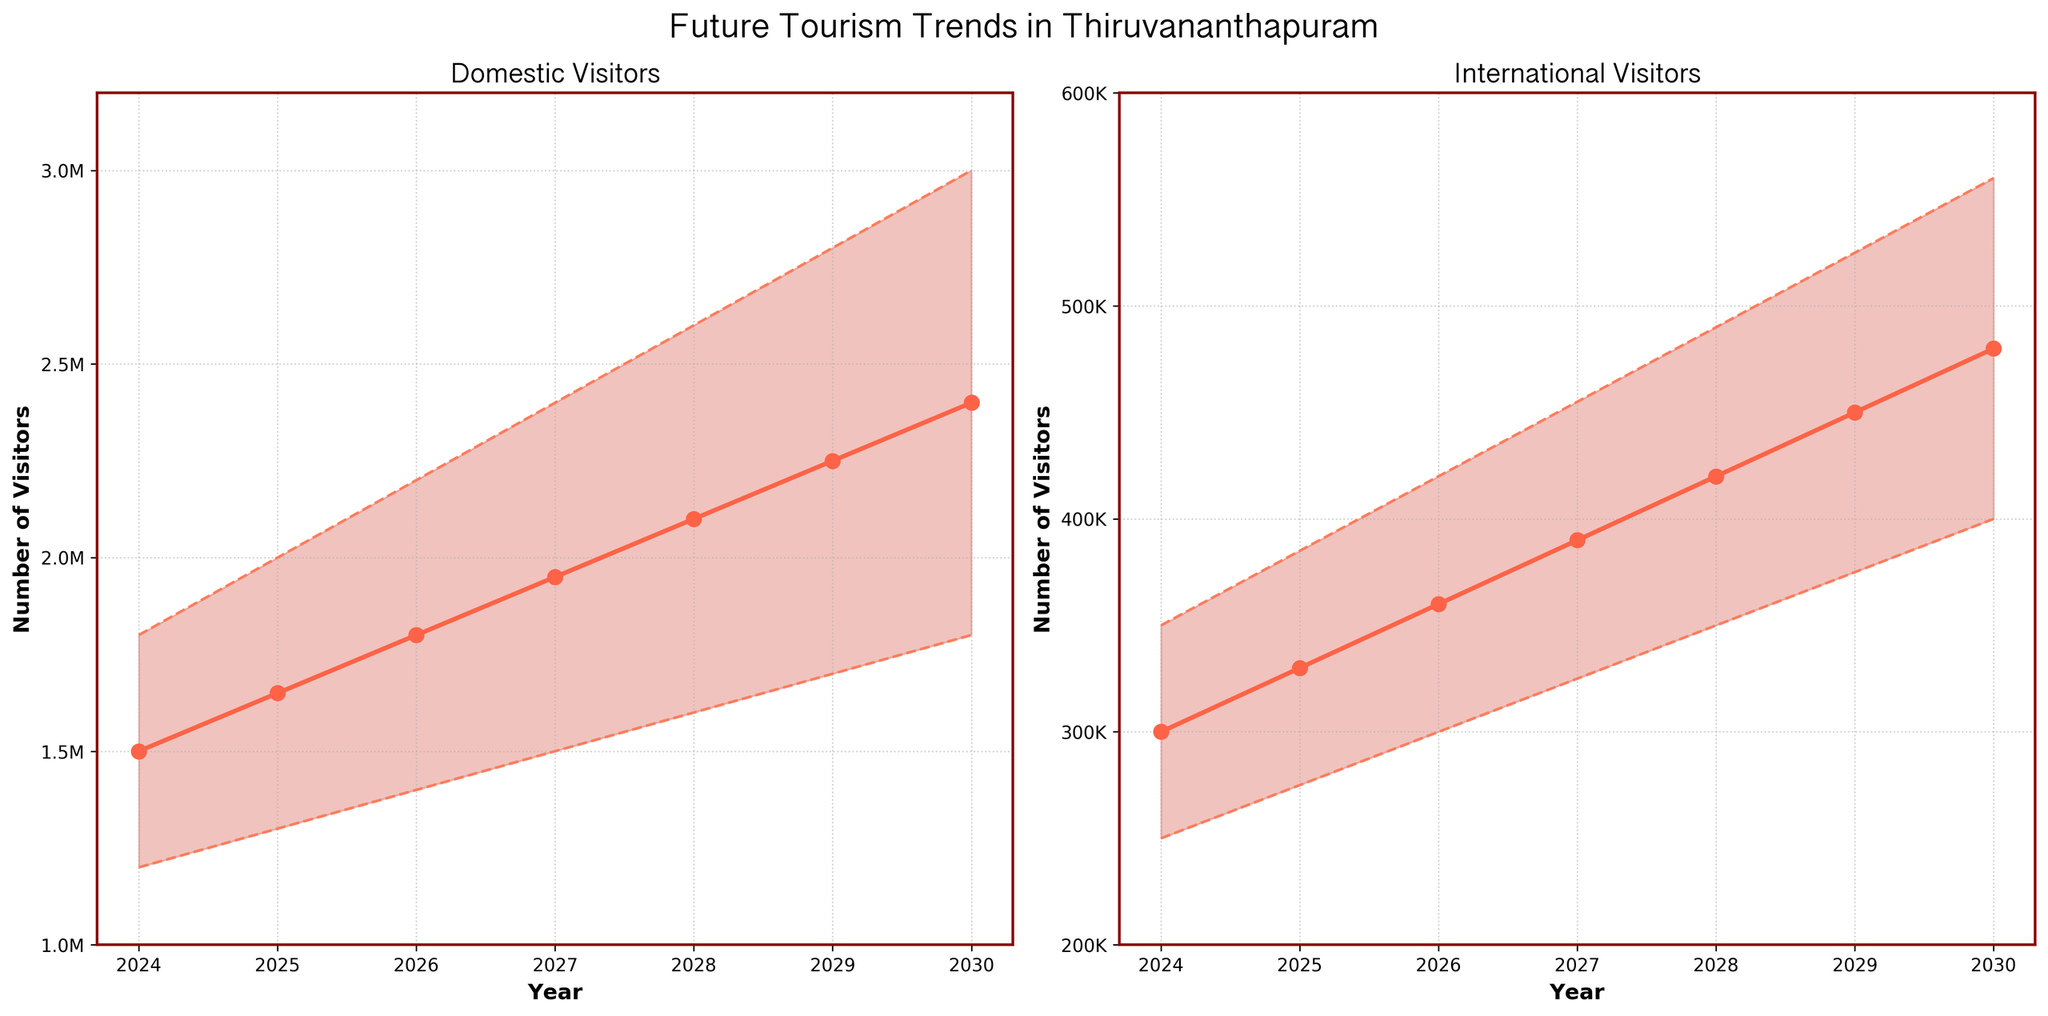What is the title of the figure? The title is typically found at the top of the plot, summarizing what the figure is about.
Answer: Future Tourism Trends in Thiruvananthapuram What does the orange shaded area represent in the 'Domestic Visitors' plot? The shaded area represents uncertainty in the projections, with the lower boundary indicating the lowest estimate and the upper boundary indicating the highest estimate.
Answer: Range of estimates By how much do the mid-level estimates of domestic visitors increase from 2024 to 2030? Subtract the number of mid-level estimates for the year 2024 from the year 2030. 2400000 - 1500000 = 900000
Answer: 900000 In which year does the high estimate of international visitors reach 420000? Look for the year where the high estimate line for international visitors intersects 420000.
Answer: 2026 Which year has the highest low estimate for international visitors? Compare the low estimate values across the years and identify the highest one.
Answer: 2030 Are the mid-level estimates of domestic visitors always higher than 1 million? Check every year's mid-level estimate for domestic visitors to see if they are greater than 1 million.
Answer: Yes What is the expected number of domestic visitors in 2029 according to the low estimate? Locate the low estimate line for 2029 in the 'Domestic Visitors' plot.
Answer: 1700000 Which visitor type shows a higher rate of increase in mid-level estimates from 2024 to 2030? Calculate the rate of increase for both visitor types, then compare them. Domestic: 2400000 - 1500000 = 900000; International: 480000 - 300000 = 180000. The domestic visitors have a higher rate.
Answer: Domestic Between which years does the highest estimate for international visitors exceed 500000 for the first time? Identify the years where the highest estimate for international visitors goes from below 500000 to above 500000.
Answer: Between 2028 and 2029 